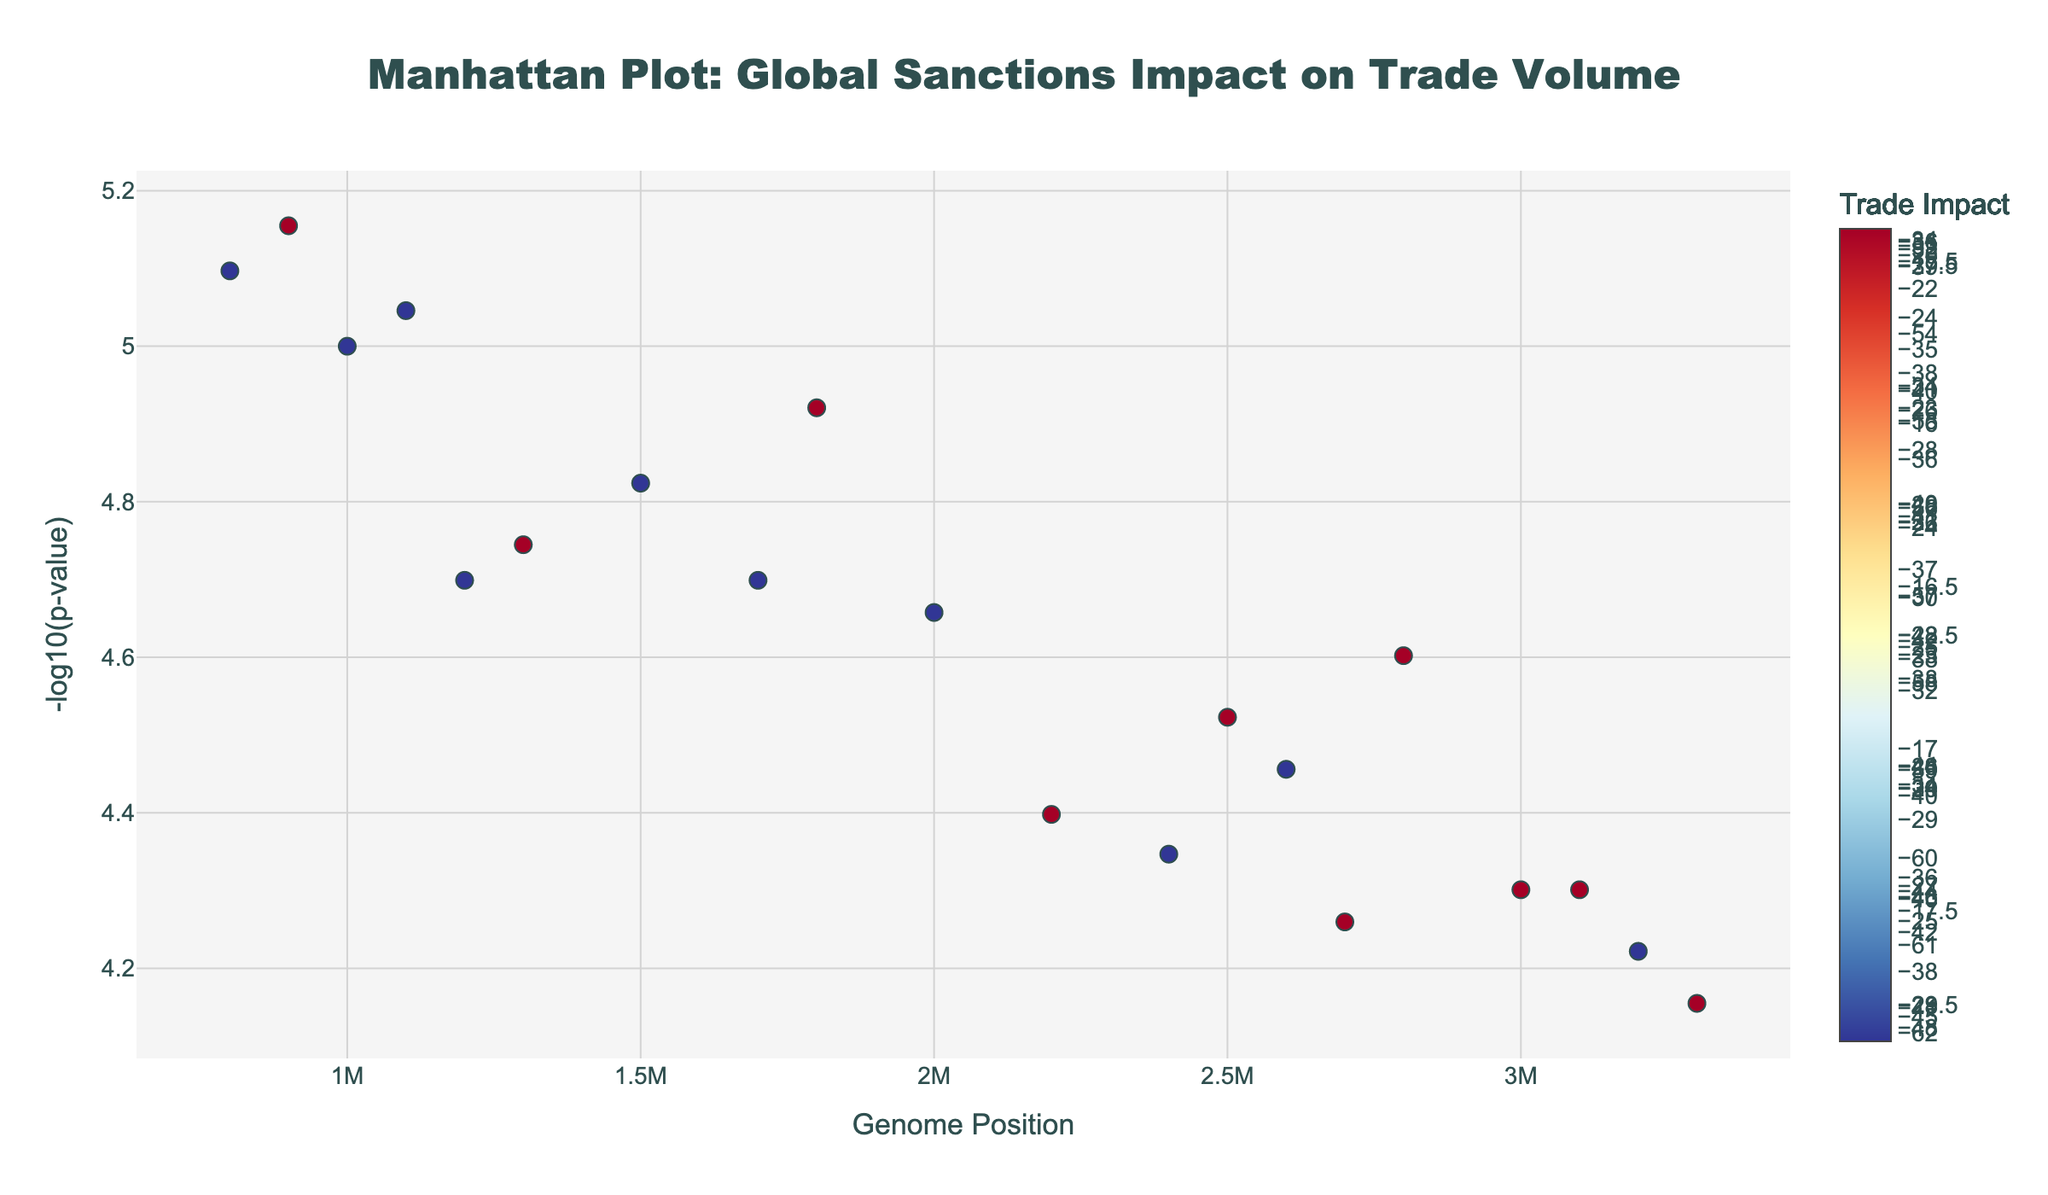What is the country with the highest trade impact? The plot shows different countries and their corresponding trade impacts. By looking at the color scale and the Trade Impact values, North Korea has the highest negative trade impact at -62.1.
Answer: North Korea Which chromosome has the highest -log10(p-value)? To find this, we look for the highest point on the y-axis, which indicates the largest -log10(p-value). The highest -log10(p-value) appears on Chromosome 3, with Venezuela having -log10(0.000008) ≈ 5.10.
Answer: Chromosome 3 Are there more countries with a trade impact less than -30 or more than -30? By counting the number of points with trade impacts less than -30 and more than -30 from the color scale and the Trade Impact values, there are more countries with trade impacts less than -30.
Answer: Less than -30 What is the average position of data points on Chromosome 1? The positions on Chromosome 1 are 1,000,000 and 2,500,000. The average is calculated as (1,000,000 + 2,500,000) / 2 = 1,750,000.
Answer: 1,750,000 Which country is represented by the point at position 3200000 on Chromosome 5? By identifying the position 3,200,000 on Chromosome 5, the hover text indicates that this point represents Belarus.
Answer: Belarus How many countries have a -log10(p-value) greater than 4? By examining the plot, we spot countries that have -log10(p-values) greater than 4 (i.e., p-values less than 0.0001). The countries are Venezuela, Syria, and Afghanistan, totaling 3 countries.
Answer: 3 countries Between which two chromosomes can you find the countries with the two highest trade impacts? Looking at the trade impacts and the corresponding chromosomes, North Korea on Chromosome 2 (-62.1) and Iran on Chromosome 2 (-52.8) have the highest impacts.
Answer: Chromosome 2 What is the color scheme used for indicating Trade Impact in the plot? The color scheme for Trade Impact ranges from red to blue through yellow, based on the color scale mentioned, which is the RdYlBu_r (Red-Yellow-Blue reversed) color scale.
Answer: Red-Yellow-Blue reversed (RdYlBu_r) Which Chromosome shows the most significant variance in Trade Impact values? By comparing the spread of Trade Impact on each Chromosome, Chromosome 2 shows the most significant variance with impacts ranging from -62.1 to -52.8 for North Korea and Iran, respectively.
Answer: Chromosome 2 